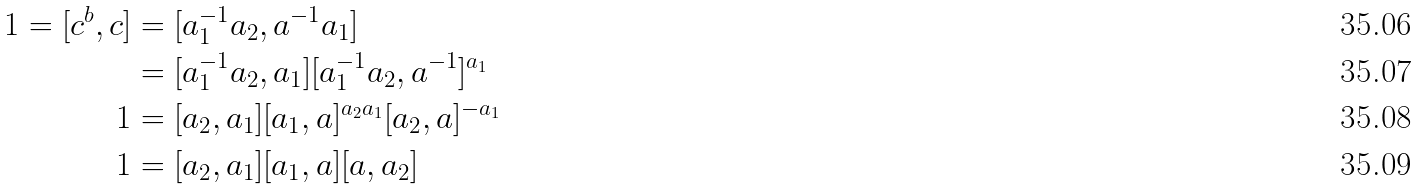Convert formula to latex. <formula><loc_0><loc_0><loc_500><loc_500>1 = [ c ^ { b } , c ] & = [ a _ { 1 } ^ { - 1 } a _ { 2 } , a ^ { - 1 } a _ { 1 } ] \\ & = [ a _ { 1 } ^ { - 1 } a _ { 2 } , a _ { 1 } ] [ a _ { 1 } ^ { - 1 } a _ { 2 } , a ^ { - 1 } ] ^ { a _ { 1 } } \\ 1 & = [ a _ { 2 } , a _ { 1 } ] [ a _ { 1 } , a ] ^ { a _ { 2 } a _ { 1 } } [ a _ { 2 } , a ] ^ { - a _ { 1 } } \\ 1 & = [ a _ { 2 } , a _ { 1 } ] [ a _ { 1 } , a ] [ a , a _ { 2 } ]</formula> 